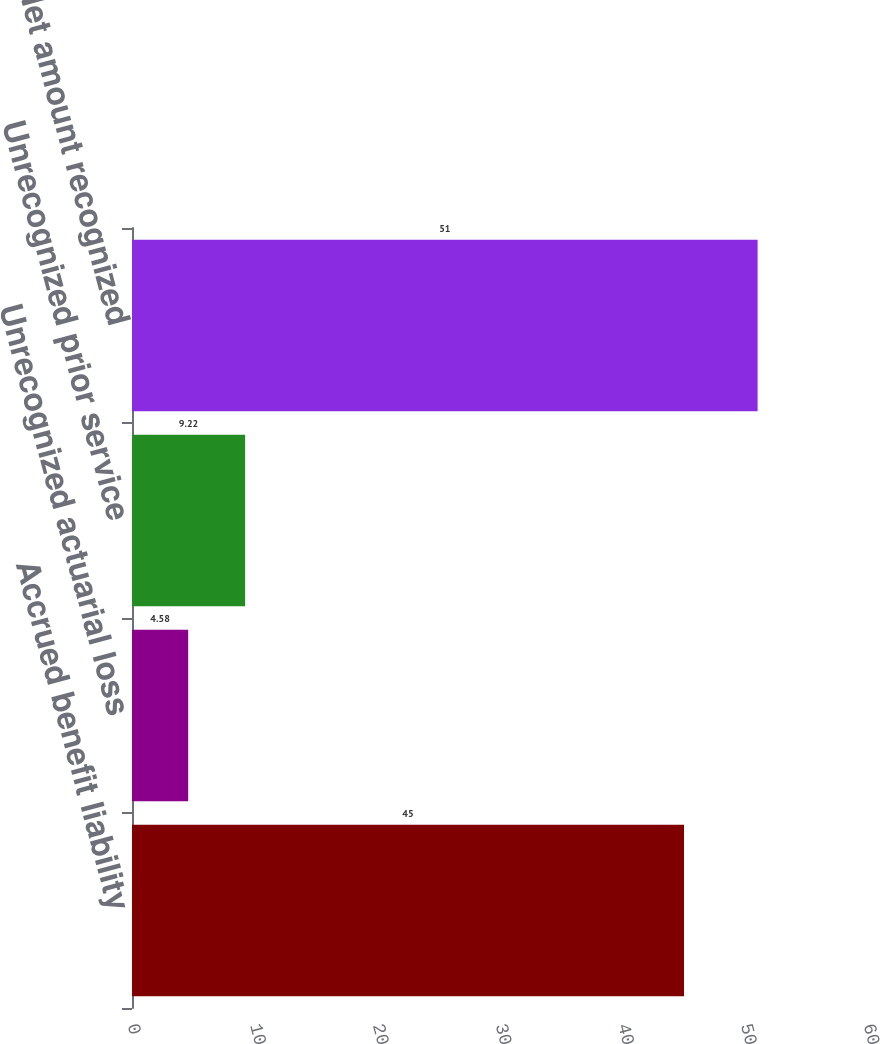<chart> <loc_0><loc_0><loc_500><loc_500><bar_chart><fcel>Accrued benefit liability<fcel>Unrecognized actuarial loss<fcel>Unrecognized prior service<fcel>Net amount recognized<nl><fcel>45<fcel>4.58<fcel>9.22<fcel>51<nl></chart> 